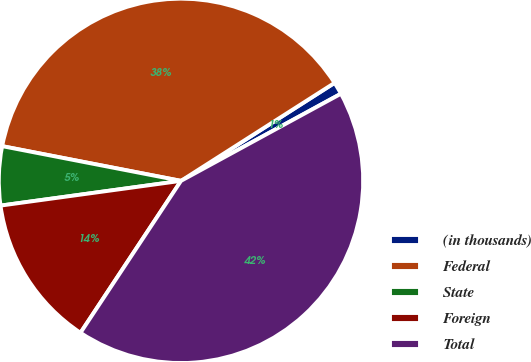Convert chart. <chart><loc_0><loc_0><loc_500><loc_500><pie_chart><fcel>(in thousands)<fcel>Federal<fcel>State<fcel>Foreign<fcel>Total<nl><fcel>1.1%<fcel>37.91%<fcel>5.22%<fcel>13.53%<fcel>42.24%<nl></chart> 